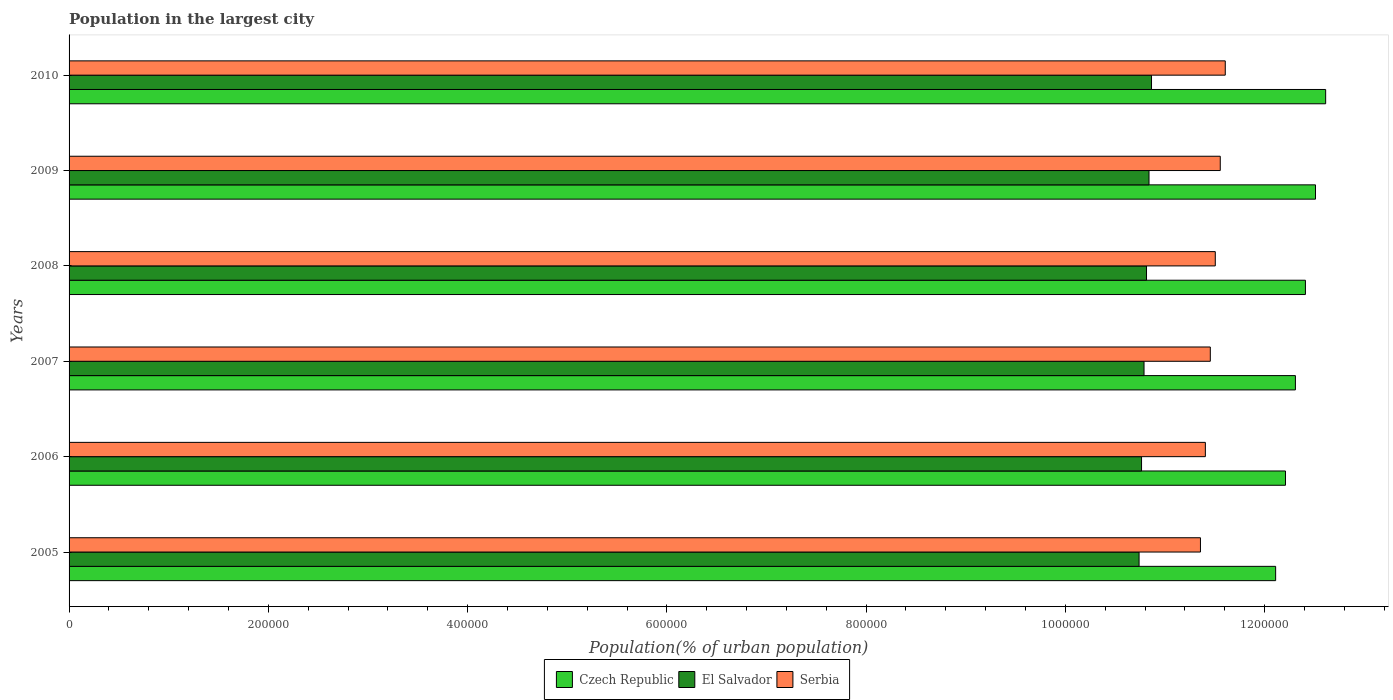How many different coloured bars are there?
Ensure brevity in your answer.  3. How many groups of bars are there?
Make the answer very short. 6. Are the number of bars per tick equal to the number of legend labels?
Offer a terse response. Yes. Are the number of bars on each tick of the Y-axis equal?
Your answer should be very brief. Yes. How many bars are there on the 3rd tick from the top?
Keep it short and to the point. 3. What is the label of the 6th group of bars from the top?
Your answer should be very brief. 2005. What is the population in the largest city in Serbia in 2009?
Your answer should be compact. 1.16e+06. Across all years, what is the maximum population in the largest city in Czech Republic?
Offer a very short reply. 1.26e+06. Across all years, what is the minimum population in the largest city in Czech Republic?
Offer a terse response. 1.21e+06. What is the total population in the largest city in El Salvador in the graph?
Your answer should be compact. 6.48e+06. What is the difference between the population in the largest city in Serbia in 2008 and that in 2009?
Your response must be concise. -4996. What is the difference between the population in the largest city in Serbia in 2010 and the population in the largest city in El Salvador in 2005?
Offer a very short reply. 8.65e+04. What is the average population in the largest city in El Salvador per year?
Keep it short and to the point. 1.08e+06. In the year 2007, what is the difference between the population in the largest city in El Salvador and population in the largest city in Czech Republic?
Offer a very short reply. -1.52e+05. What is the ratio of the population in the largest city in Serbia in 2007 to that in 2008?
Offer a very short reply. 1. What is the difference between the highest and the second highest population in the largest city in Czech Republic?
Your response must be concise. 1.02e+04. What is the difference between the highest and the lowest population in the largest city in Czech Republic?
Your answer should be very brief. 5.02e+04. In how many years, is the population in the largest city in Czech Republic greater than the average population in the largest city in Czech Republic taken over all years?
Make the answer very short. 3. Is the sum of the population in the largest city in Czech Republic in 2005 and 2010 greater than the maximum population in the largest city in El Salvador across all years?
Offer a very short reply. Yes. What does the 2nd bar from the top in 2009 represents?
Offer a very short reply. El Salvador. What does the 2nd bar from the bottom in 2005 represents?
Provide a succinct answer. El Salvador. Are all the bars in the graph horizontal?
Keep it short and to the point. Yes. What is the difference between two consecutive major ticks on the X-axis?
Provide a succinct answer. 2.00e+05. Does the graph contain any zero values?
Give a very brief answer. No. Does the graph contain grids?
Offer a terse response. No. Where does the legend appear in the graph?
Provide a succinct answer. Bottom center. How many legend labels are there?
Your answer should be compact. 3. How are the legend labels stacked?
Your answer should be compact. Horizontal. What is the title of the graph?
Your response must be concise. Population in the largest city. What is the label or title of the X-axis?
Offer a terse response. Population(% of urban population). What is the Population(% of urban population) of Czech Republic in 2005?
Keep it short and to the point. 1.21e+06. What is the Population(% of urban population) of El Salvador in 2005?
Your answer should be very brief. 1.07e+06. What is the Population(% of urban population) in Serbia in 2005?
Make the answer very short. 1.14e+06. What is the Population(% of urban population) of Czech Republic in 2006?
Offer a terse response. 1.22e+06. What is the Population(% of urban population) of El Salvador in 2006?
Offer a very short reply. 1.08e+06. What is the Population(% of urban population) of Serbia in 2006?
Your answer should be compact. 1.14e+06. What is the Population(% of urban population) in Czech Republic in 2007?
Keep it short and to the point. 1.23e+06. What is the Population(% of urban population) in El Salvador in 2007?
Your answer should be very brief. 1.08e+06. What is the Population(% of urban population) of Serbia in 2007?
Your answer should be very brief. 1.15e+06. What is the Population(% of urban population) of Czech Republic in 2008?
Offer a very short reply. 1.24e+06. What is the Population(% of urban population) of El Salvador in 2008?
Ensure brevity in your answer.  1.08e+06. What is the Population(% of urban population) in Serbia in 2008?
Provide a short and direct response. 1.15e+06. What is the Population(% of urban population) in Czech Republic in 2009?
Keep it short and to the point. 1.25e+06. What is the Population(% of urban population) in El Salvador in 2009?
Offer a very short reply. 1.08e+06. What is the Population(% of urban population) of Serbia in 2009?
Offer a very short reply. 1.16e+06. What is the Population(% of urban population) in Czech Republic in 2010?
Provide a succinct answer. 1.26e+06. What is the Population(% of urban population) in El Salvador in 2010?
Give a very brief answer. 1.09e+06. What is the Population(% of urban population) in Serbia in 2010?
Your answer should be very brief. 1.16e+06. Across all years, what is the maximum Population(% of urban population) in Czech Republic?
Offer a very short reply. 1.26e+06. Across all years, what is the maximum Population(% of urban population) in El Salvador?
Your answer should be compact. 1.09e+06. Across all years, what is the maximum Population(% of urban population) in Serbia?
Your response must be concise. 1.16e+06. Across all years, what is the minimum Population(% of urban population) of Czech Republic?
Give a very brief answer. 1.21e+06. Across all years, what is the minimum Population(% of urban population) in El Salvador?
Offer a very short reply. 1.07e+06. Across all years, what is the minimum Population(% of urban population) of Serbia?
Offer a very short reply. 1.14e+06. What is the total Population(% of urban population) in Czech Republic in the graph?
Ensure brevity in your answer.  7.42e+06. What is the total Population(% of urban population) in El Salvador in the graph?
Provide a short and direct response. 6.48e+06. What is the total Population(% of urban population) in Serbia in the graph?
Give a very brief answer. 6.89e+06. What is the difference between the Population(% of urban population) in Czech Republic in 2005 and that in 2006?
Your response must be concise. -9879. What is the difference between the Population(% of urban population) of El Salvador in 2005 and that in 2006?
Give a very brief answer. -2485. What is the difference between the Population(% of urban population) in Serbia in 2005 and that in 2006?
Offer a terse response. -4939. What is the difference between the Population(% of urban population) in Czech Republic in 2005 and that in 2007?
Offer a very short reply. -1.98e+04. What is the difference between the Population(% of urban population) of El Salvador in 2005 and that in 2007?
Give a very brief answer. -4976. What is the difference between the Population(% of urban population) in Serbia in 2005 and that in 2007?
Your answer should be very brief. -9900. What is the difference between the Population(% of urban population) in Czech Republic in 2005 and that in 2008?
Your answer should be very brief. -2.99e+04. What is the difference between the Population(% of urban population) of El Salvador in 2005 and that in 2008?
Your answer should be compact. -7476. What is the difference between the Population(% of urban population) in Serbia in 2005 and that in 2008?
Provide a succinct answer. -1.49e+04. What is the difference between the Population(% of urban population) of Czech Republic in 2005 and that in 2009?
Keep it short and to the point. -4.00e+04. What is the difference between the Population(% of urban population) in El Salvador in 2005 and that in 2009?
Your answer should be compact. -9974. What is the difference between the Population(% of urban population) of Serbia in 2005 and that in 2009?
Make the answer very short. -1.99e+04. What is the difference between the Population(% of urban population) of Czech Republic in 2005 and that in 2010?
Offer a very short reply. -5.02e+04. What is the difference between the Population(% of urban population) of El Salvador in 2005 and that in 2010?
Give a very brief answer. -1.25e+04. What is the difference between the Population(% of urban population) in Serbia in 2005 and that in 2010?
Provide a succinct answer. -2.49e+04. What is the difference between the Population(% of urban population) of Czech Republic in 2006 and that in 2007?
Provide a succinct answer. -9960. What is the difference between the Population(% of urban population) of El Salvador in 2006 and that in 2007?
Provide a succinct answer. -2491. What is the difference between the Population(% of urban population) in Serbia in 2006 and that in 2007?
Offer a very short reply. -4961. What is the difference between the Population(% of urban population) of Czech Republic in 2006 and that in 2008?
Ensure brevity in your answer.  -2.00e+04. What is the difference between the Population(% of urban population) of El Salvador in 2006 and that in 2008?
Ensure brevity in your answer.  -4991. What is the difference between the Population(% of urban population) in Serbia in 2006 and that in 2008?
Give a very brief answer. -9950. What is the difference between the Population(% of urban population) in Czech Republic in 2006 and that in 2009?
Ensure brevity in your answer.  -3.01e+04. What is the difference between the Population(% of urban population) in El Salvador in 2006 and that in 2009?
Ensure brevity in your answer.  -7489. What is the difference between the Population(% of urban population) of Serbia in 2006 and that in 2009?
Give a very brief answer. -1.49e+04. What is the difference between the Population(% of urban population) of Czech Republic in 2006 and that in 2010?
Make the answer very short. -4.03e+04. What is the difference between the Population(% of urban population) of El Salvador in 2006 and that in 2010?
Offer a very short reply. -9998. What is the difference between the Population(% of urban population) of Serbia in 2006 and that in 2010?
Ensure brevity in your answer.  -2.00e+04. What is the difference between the Population(% of urban population) of Czech Republic in 2007 and that in 2008?
Give a very brief answer. -1.01e+04. What is the difference between the Population(% of urban population) in El Salvador in 2007 and that in 2008?
Your answer should be compact. -2500. What is the difference between the Population(% of urban population) of Serbia in 2007 and that in 2008?
Make the answer very short. -4989. What is the difference between the Population(% of urban population) of Czech Republic in 2007 and that in 2009?
Make the answer very short. -2.02e+04. What is the difference between the Population(% of urban population) of El Salvador in 2007 and that in 2009?
Your answer should be compact. -4998. What is the difference between the Population(% of urban population) of Serbia in 2007 and that in 2009?
Provide a succinct answer. -9985. What is the difference between the Population(% of urban population) in Czech Republic in 2007 and that in 2010?
Provide a succinct answer. -3.04e+04. What is the difference between the Population(% of urban population) in El Salvador in 2007 and that in 2010?
Your answer should be compact. -7507. What is the difference between the Population(% of urban population) in Serbia in 2007 and that in 2010?
Ensure brevity in your answer.  -1.50e+04. What is the difference between the Population(% of urban population) in Czech Republic in 2008 and that in 2009?
Give a very brief answer. -1.01e+04. What is the difference between the Population(% of urban population) in El Salvador in 2008 and that in 2009?
Make the answer very short. -2498. What is the difference between the Population(% of urban population) in Serbia in 2008 and that in 2009?
Make the answer very short. -4996. What is the difference between the Population(% of urban population) in Czech Republic in 2008 and that in 2010?
Your answer should be very brief. -2.03e+04. What is the difference between the Population(% of urban population) in El Salvador in 2008 and that in 2010?
Your answer should be compact. -5007. What is the difference between the Population(% of urban population) of Serbia in 2008 and that in 2010?
Offer a very short reply. -1.00e+04. What is the difference between the Population(% of urban population) in Czech Republic in 2009 and that in 2010?
Ensure brevity in your answer.  -1.02e+04. What is the difference between the Population(% of urban population) in El Salvador in 2009 and that in 2010?
Ensure brevity in your answer.  -2509. What is the difference between the Population(% of urban population) of Serbia in 2009 and that in 2010?
Give a very brief answer. -5026. What is the difference between the Population(% of urban population) of Czech Republic in 2005 and the Population(% of urban population) of El Salvador in 2006?
Give a very brief answer. 1.35e+05. What is the difference between the Population(% of urban population) in Czech Republic in 2005 and the Population(% of urban population) in Serbia in 2006?
Offer a very short reply. 7.05e+04. What is the difference between the Population(% of urban population) in El Salvador in 2005 and the Population(% of urban population) in Serbia in 2006?
Make the answer very short. -6.65e+04. What is the difference between the Population(% of urban population) in Czech Republic in 2005 and the Population(% of urban population) in El Salvador in 2007?
Ensure brevity in your answer.  1.32e+05. What is the difference between the Population(% of urban population) in Czech Republic in 2005 and the Population(% of urban population) in Serbia in 2007?
Ensure brevity in your answer.  6.56e+04. What is the difference between the Population(% of urban population) in El Salvador in 2005 and the Population(% of urban population) in Serbia in 2007?
Give a very brief answer. -7.15e+04. What is the difference between the Population(% of urban population) in Czech Republic in 2005 and the Population(% of urban population) in El Salvador in 2008?
Your answer should be very brief. 1.30e+05. What is the difference between the Population(% of urban population) in Czech Republic in 2005 and the Population(% of urban population) in Serbia in 2008?
Offer a very short reply. 6.06e+04. What is the difference between the Population(% of urban population) of El Salvador in 2005 and the Population(% of urban population) of Serbia in 2008?
Your response must be concise. -7.65e+04. What is the difference between the Population(% of urban population) of Czech Republic in 2005 and the Population(% of urban population) of El Salvador in 2009?
Your answer should be compact. 1.27e+05. What is the difference between the Population(% of urban population) in Czech Republic in 2005 and the Population(% of urban population) in Serbia in 2009?
Offer a terse response. 5.56e+04. What is the difference between the Population(% of urban population) of El Salvador in 2005 and the Population(% of urban population) of Serbia in 2009?
Give a very brief answer. -8.15e+04. What is the difference between the Population(% of urban population) in Czech Republic in 2005 and the Population(% of urban population) in El Salvador in 2010?
Your answer should be very brief. 1.25e+05. What is the difference between the Population(% of urban population) of Czech Republic in 2005 and the Population(% of urban population) of Serbia in 2010?
Ensure brevity in your answer.  5.06e+04. What is the difference between the Population(% of urban population) in El Salvador in 2005 and the Population(% of urban population) in Serbia in 2010?
Your answer should be compact. -8.65e+04. What is the difference between the Population(% of urban population) of Czech Republic in 2006 and the Population(% of urban population) of El Salvador in 2007?
Provide a succinct answer. 1.42e+05. What is the difference between the Population(% of urban population) in Czech Republic in 2006 and the Population(% of urban population) in Serbia in 2007?
Your response must be concise. 7.54e+04. What is the difference between the Population(% of urban population) in El Salvador in 2006 and the Population(% of urban population) in Serbia in 2007?
Keep it short and to the point. -6.90e+04. What is the difference between the Population(% of urban population) of Czech Republic in 2006 and the Population(% of urban population) of El Salvador in 2008?
Your answer should be compact. 1.39e+05. What is the difference between the Population(% of urban population) in Czech Republic in 2006 and the Population(% of urban population) in Serbia in 2008?
Ensure brevity in your answer.  7.05e+04. What is the difference between the Population(% of urban population) in El Salvador in 2006 and the Population(% of urban population) in Serbia in 2008?
Your answer should be compact. -7.40e+04. What is the difference between the Population(% of urban population) of Czech Republic in 2006 and the Population(% of urban population) of El Salvador in 2009?
Provide a short and direct response. 1.37e+05. What is the difference between the Population(% of urban population) of Czech Republic in 2006 and the Population(% of urban population) of Serbia in 2009?
Make the answer very short. 6.55e+04. What is the difference between the Population(% of urban population) in El Salvador in 2006 and the Population(% of urban population) in Serbia in 2009?
Your response must be concise. -7.90e+04. What is the difference between the Population(% of urban population) in Czech Republic in 2006 and the Population(% of urban population) in El Salvador in 2010?
Make the answer very short. 1.34e+05. What is the difference between the Population(% of urban population) of Czech Republic in 2006 and the Population(% of urban population) of Serbia in 2010?
Offer a very short reply. 6.04e+04. What is the difference between the Population(% of urban population) of El Salvador in 2006 and the Population(% of urban population) of Serbia in 2010?
Your answer should be compact. -8.40e+04. What is the difference between the Population(% of urban population) of Czech Republic in 2007 and the Population(% of urban population) of El Salvador in 2008?
Provide a short and direct response. 1.49e+05. What is the difference between the Population(% of urban population) of Czech Republic in 2007 and the Population(% of urban population) of Serbia in 2008?
Provide a succinct answer. 8.04e+04. What is the difference between the Population(% of urban population) of El Salvador in 2007 and the Population(% of urban population) of Serbia in 2008?
Make the answer very short. -7.15e+04. What is the difference between the Population(% of urban population) of Czech Republic in 2007 and the Population(% of urban population) of El Salvador in 2009?
Your answer should be very brief. 1.47e+05. What is the difference between the Population(% of urban population) of Czech Republic in 2007 and the Population(% of urban population) of Serbia in 2009?
Ensure brevity in your answer.  7.54e+04. What is the difference between the Population(% of urban population) in El Salvador in 2007 and the Population(% of urban population) in Serbia in 2009?
Your response must be concise. -7.65e+04. What is the difference between the Population(% of urban population) of Czech Republic in 2007 and the Population(% of urban population) of El Salvador in 2010?
Offer a terse response. 1.44e+05. What is the difference between the Population(% of urban population) in Czech Republic in 2007 and the Population(% of urban population) in Serbia in 2010?
Provide a succinct answer. 7.04e+04. What is the difference between the Population(% of urban population) in El Salvador in 2007 and the Population(% of urban population) in Serbia in 2010?
Give a very brief answer. -8.15e+04. What is the difference between the Population(% of urban population) of Czech Republic in 2008 and the Population(% of urban population) of El Salvador in 2009?
Provide a succinct answer. 1.57e+05. What is the difference between the Population(% of urban population) of Czech Republic in 2008 and the Population(% of urban population) of Serbia in 2009?
Offer a terse response. 8.55e+04. What is the difference between the Population(% of urban population) in El Salvador in 2008 and the Population(% of urban population) in Serbia in 2009?
Your answer should be compact. -7.40e+04. What is the difference between the Population(% of urban population) in Czech Republic in 2008 and the Population(% of urban population) in El Salvador in 2010?
Ensure brevity in your answer.  1.54e+05. What is the difference between the Population(% of urban population) in Czech Republic in 2008 and the Population(% of urban population) in Serbia in 2010?
Give a very brief answer. 8.05e+04. What is the difference between the Population(% of urban population) of El Salvador in 2008 and the Population(% of urban population) of Serbia in 2010?
Ensure brevity in your answer.  -7.90e+04. What is the difference between the Population(% of urban population) in Czech Republic in 2009 and the Population(% of urban population) in El Salvador in 2010?
Give a very brief answer. 1.65e+05. What is the difference between the Population(% of urban population) of Czech Republic in 2009 and the Population(% of urban population) of Serbia in 2010?
Offer a terse response. 9.06e+04. What is the difference between the Population(% of urban population) in El Salvador in 2009 and the Population(% of urban population) in Serbia in 2010?
Provide a short and direct response. -7.65e+04. What is the average Population(% of urban population) of Czech Republic per year?
Offer a very short reply. 1.24e+06. What is the average Population(% of urban population) in El Salvador per year?
Your answer should be very brief. 1.08e+06. What is the average Population(% of urban population) of Serbia per year?
Your answer should be very brief. 1.15e+06. In the year 2005, what is the difference between the Population(% of urban population) in Czech Republic and Population(% of urban population) in El Salvador?
Ensure brevity in your answer.  1.37e+05. In the year 2005, what is the difference between the Population(% of urban population) in Czech Republic and Population(% of urban population) in Serbia?
Your answer should be compact. 7.55e+04. In the year 2005, what is the difference between the Population(% of urban population) in El Salvador and Population(% of urban population) in Serbia?
Provide a short and direct response. -6.16e+04. In the year 2006, what is the difference between the Population(% of urban population) in Czech Republic and Population(% of urban population) in El Salvador?
Provide a succinct answer. 1.44e+05. In the year 2006, what is the difference between the Population(% of urban population) in Czech Republic and Population(% of urban population) in Serbia?
Your answer should be compact. 8.04e+04. In the year 2006, what is the difference between the Population(% of urban population) of El Salvador and Population(% of urban population) of Serbia?
Your answer should be very brief. -6.41e+04. In the year 2007, what is the difference between the Population(% of urban population) of Czech Republic and Population(% of urban population) of El Salvador?
Provide a short and direct response. 1.52e+05. In the year 2007, what is the difference between the Population(% of urban population) in Czech Republic and Population(% of urban population) in Serbia?
Make the answer very short. 8.54e+04. In the year 2007, what is the difference between the Population(% of urban population) in El Salvador and Population(% of urban population) in Serbia?
Your response must be concise. -6.65e+04. In the year 2008, what is the difference between the Population(% of urban population) in Czech Republic and Population(% of urban population) in El Salvador?
Your answer should be very brief. 1.59e+05. In the year 2008, what is the difference between the Population(% of urban population) in Czech Republic and Population(% of urban population) in Serbia?
Give a very brief answer. 9.05e+04. In the year 2008, what is the difference between the Population(% of urban population) in El Salvador and Population(% of urban population) in Serbia?
Provide a short and direct response. -6.90e+04. In the year 2009, what is the difference between the Population(% of urban population) of Czech Republic and Population(% of urban population) of El Salvador?
Provide a succinct answer. 1.67e+05. In the year 2009, what is the difference between the Population(% of urban population) of Czech Republic and Population(% of urban population) of Serbia?
Provide a succinct answer. 9.56e+04. In the year 2009, what is the difference between the Population(% of urban population) of El Salvador and Population(% of urban population) of Serbia?
Your response must be concise. -7.15e+04. In the year 2010, what is the difference between the Population(% of urban population) of Czech Republic and Population(% of urban population) of El Salvador?
Offer a very short reply. 1.75e+05. In the year 2010, what is the difference between the Population(% of urban population) in Czech Republic and Population(% of urban population) in Serbia?
Keep it short and to the point. 1.01e+05. In the year 2010, what is the difference between the Population(% of urban population) in El Salvador and Population(% of urban population) in Serbia?
Offer a terse response. -7.40e+04. What is the ratio of the Population(% of urban population) of Serbia in 2005 to that in 2006?
Provide a short and direct response. 1. What is the ratio of the Population(% of urban population) in Czech Republic in 2005 to that in 2007?
Ensure brevity in your answer.  0.98. What is the ratio of the Population(% of urban population) of Czech Republic in 2005 to that in 2008?
Ensure brevity in your answer.  0.98. What is the ratio of the Population(% of urban population) of Serbia in 2005 to that in 2008?
Ensure brevity in your answer.  0.99. What is the ratio of the Population(% of urban population) in Serbia in 2005 to that in 2009?
Keep it short and to the point. 0.98. What is the ratio of the Population(% of urban population) in Czech Republic in 2005 to that in 2010?
Make the answer very short. 0.96. What is the ratio of the Population(% of urban population) in Serbia in 2005 to that in 2010?
Keep it short and to the point. 0.98. What is the ratio of the Population(% of urban population) of Czech Republic in 2006 to that in 2007?
Make the answer very short. 0.99. What is the ratio of the Population(% of urban population) of El Salvador in 2006 to that in 2007?
Offer a terse response. 1. What is the ratio of the Population(% of urban population) in Czech Republic in 2006 to that in 2008?
Ensure brevity in your answer.  0.98. What is the ratio of the Population(% of urban population) of Serbia in 2006 to that in 2008?
Your response must be concise. 0.99. What is the ratio of the Population(% of urban population) of Czech Republic in 2006 to that in 2009?
Your answer should be very brief. 0.98. What is the ratio of the Population(% of urban population) in Serbia in 2006 to that in 2009?
Provide a short and direct response. 0.99. What is the ratio of the Population(% of urban population) of Serbia in 2006 to that in 2010?
Offer a terse response. 0.98. What is the ratio of the Population(% of urban population) of Czech Republic in 2007 to that in 2008?
Your answer should be compact. 0.99. What is the ratio of the Population(% of urban population) of El Salvador in 2007 to that in 2008?
Offer a very short reply. 1. What is the ratio of the Population(% of urban population) in Serbia in 2007 to that in 2008?
Offer a terse response. 1. What is the ratio of the Population(% of urban population) in Czech Republic in 2007 to that in 2009?
Provide a short and direct response. 0.98. What is the ratio of the Population(% of urban population) of El Salvador in 2007 to that in 2009?
Keep it short and to the point. 1. What is the ratio of the Population(% of urban population) in Czech Republic in 2007 to that in 2010?
Provide a short and direct response. 0.98. What is the ratio of the Population(% of urban population) in El Salvador in 2007 to that in 2010?
Offer a terse response. 0.99. What is the ratio of the Population(% of urban population) of Serbia in 2007 to that in 2010?
Provide a short and direct response. 0.99. What is the ratio of the Population(% of urban population) of Czech Republic in 2008 to that in 2009?
Keep it short and to the point. 0.99. What is the ratio of the Population(% of urban population) in El Salvador in 2008 to that in 2009?
Ensure brevity in your answer.  1. What is the ratio of the Population(% of urban population) of Serbia in 2008 to that in 2009?
Make the answer very short. 1. What is the ratio of the Population(% of urban population) in Czech Republic in 2008 to that in 2010?
Your answer should be very brief. 0.98. What is the ratio of the Population(% of urban population) in El Salvador in 2009 to that in 2010?
Your answer should be compact. 1. What is the difference between the highest and the second highest Population(% of urban population) of Czech Republic?
Give a very brief answer. 1.02e+04. What is the difference between the highest and the second highest Population(% of urban population) in El Salvador?
Give a very brief answer. 2509. What is the difference between the highest and the second highest Population(% of urban population) in Serbia?
Your answer should be very brief. 5026. What is the difference between the highest and the lowest Population(% of urban population) of Czech Republic?
Make the answer very short. 5.02e+04. What is the difference between the highest and the lowest Population(% of urban population) in El Salvador?
Provide a short and direct response. 1.25e+04. What is the difference between the highest and the lowest Population(% of urban population) of Serbia?
Provide a short and direct response. 2.49e+04. 